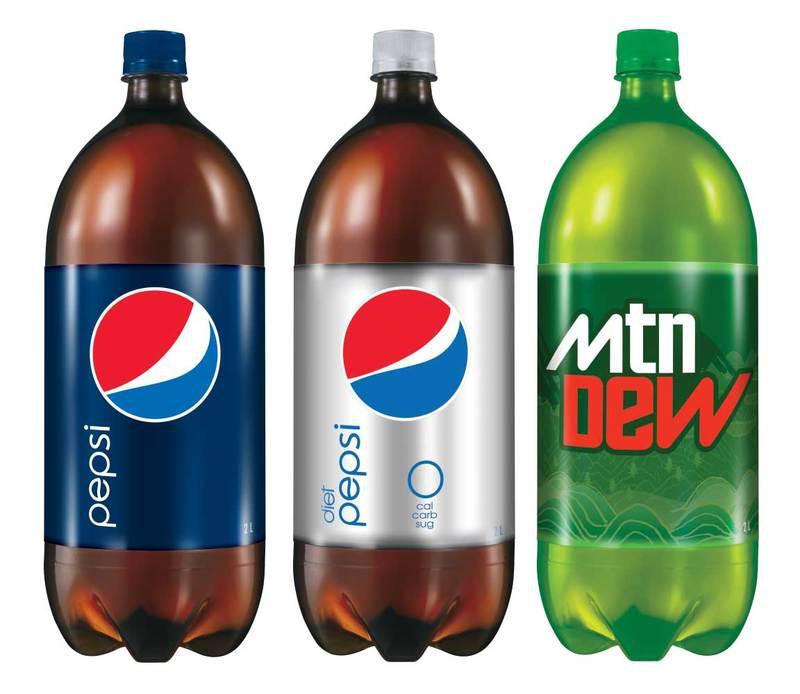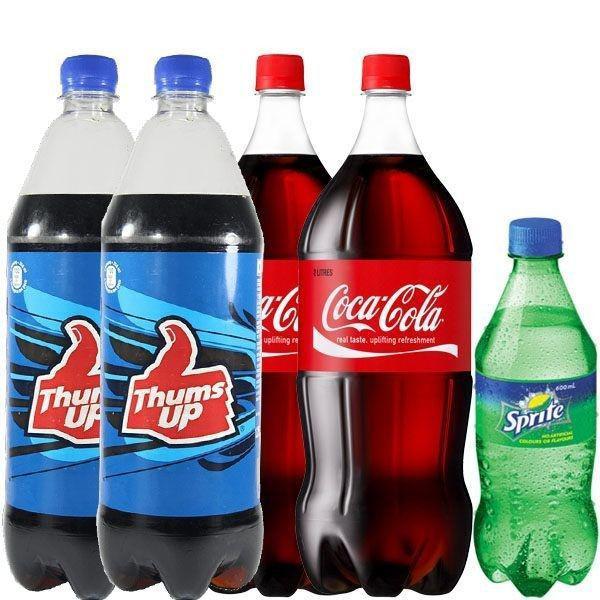The first image is the image on the left, the second image is the image on the right. Examine the images to the left and right. Is the description "The combined images contain seven soda bottles, and no two bottles are exactly the same." accurate? Answer yes or no. No. The first image is the image on the left, the second image is the image on the right. Evaluate the accuracy of this statement regarding the images: "All sodas in the left image have caffeine.". Is it true? Answer yes or no. Yes. 